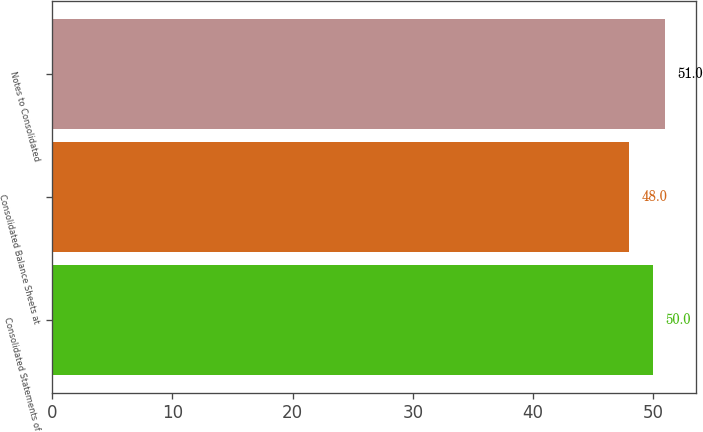Convert chart. <chart><loc_0><loc_0><loc_500><loc_500><bar_chart><fcel>Consolidated Statements of<fcel>Consolidated Balance Sheets at<fcel>Notes to Consolidated<nl><fcel>50<fcel>48<fcel>51<nl></chart> 